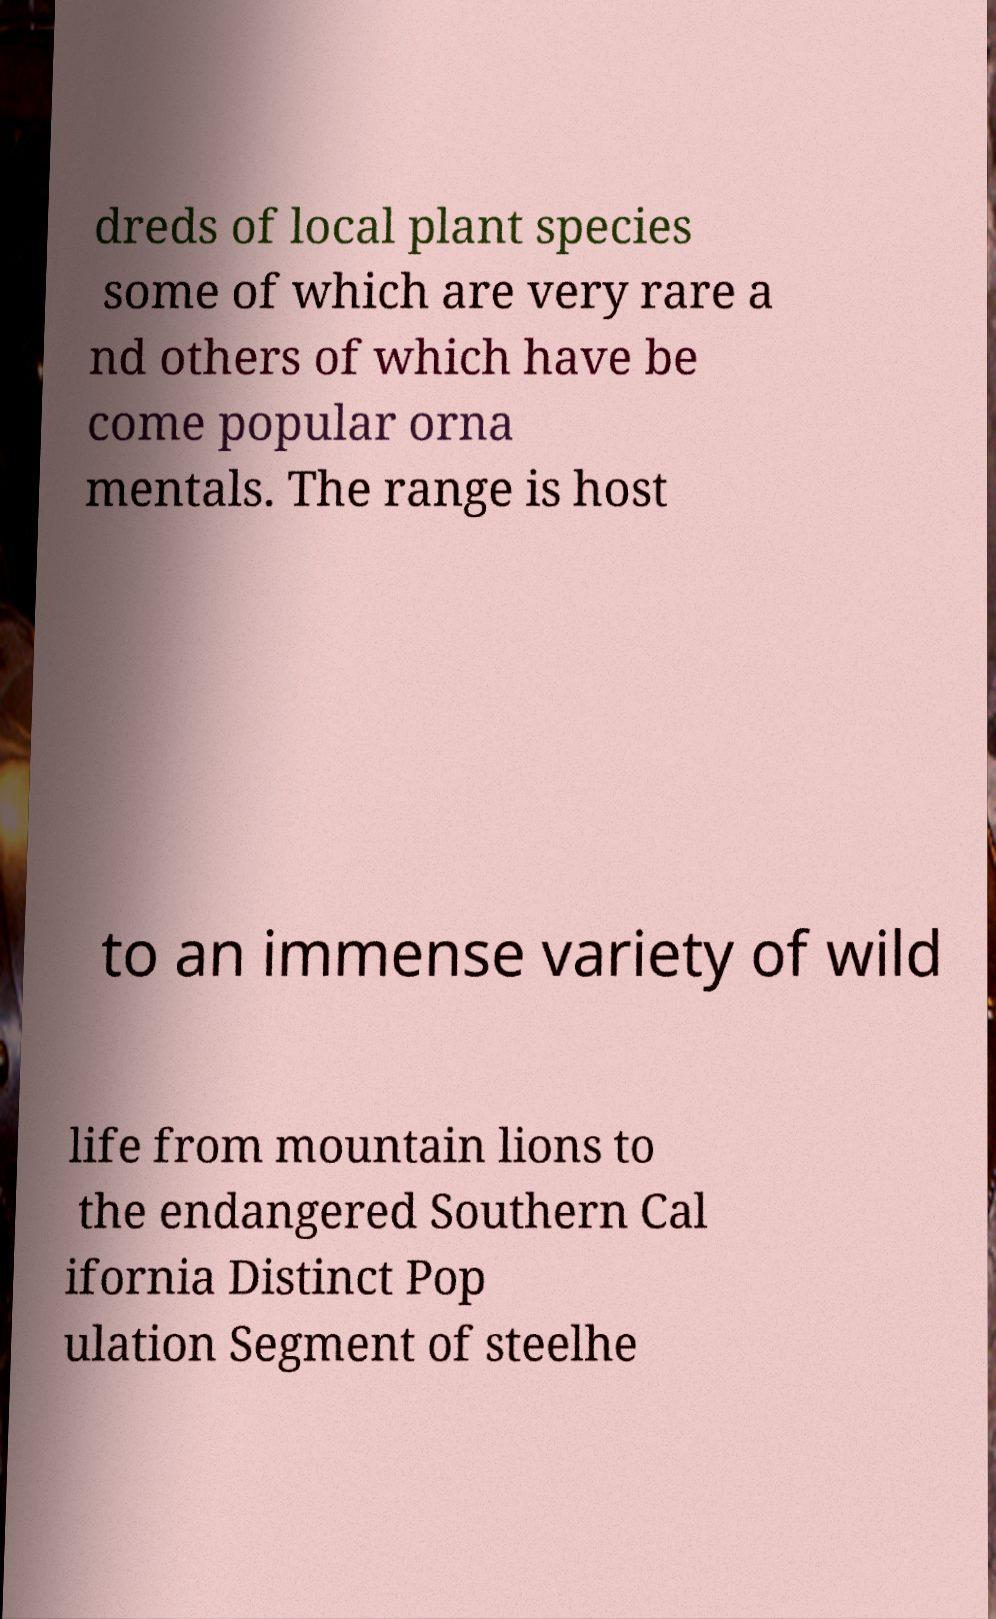Please identify and transcribe the text found in this image. dreds of local plant species some of which are very rare a nd others of which have be come popular orna mentals. The range is host to an immense variety of wild life from mountain lions to the endangered Southern Cal ifornia Distinct Pop ulation Segment of steelhe 